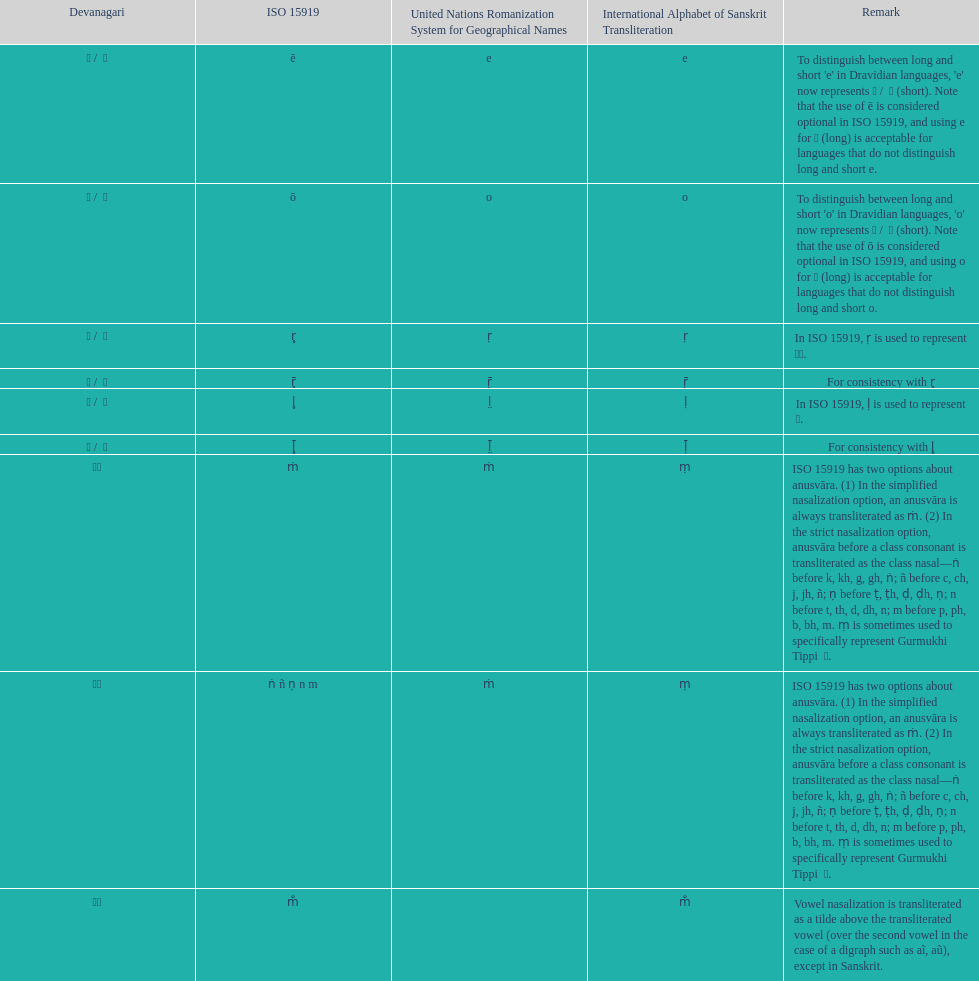Parse the full table. {'header': ['Devanagari', 'ISO 15919', 'United Nations Romanization System for Geographical Names', 'International Alphabet of Sanskrit Transliteration', 'Remark'], 'rows': [['ए / \xa0े', 'ē', 'e', 'e', "To distinguish between long and short 'e' in Dravidian languages, 'e' now represents ऎ / \xa0ॆ (short). Note that the use of ē is considered optional in ISO 15919, and using e for ए (long) is acceptable for languages that do not distinguish long and short e."], ['ओ / \xa0ो', 'ō', 'o', 'o', "To distinguish between long and short 'o' in Dravidian languages, 'o' now represents ऒ / \xa0ॊ (short). Note that the use of ō is considered optional in ISO 15919, and using o for ओ (long) is acceptable for languages that do not distinguish long and short o."], ['ऋ / \xa0ृ', 'r̥', 'ṛ', 'ṛ', 'In ISO 15919, ṛ is used to represent ड़.'], ['ॠ / \xa0ॄ', 'r̥̄', 'ṝ', 'ṝ', 'For consistency with r̥'], ['ऌ / \xa0ॢ', 'l̥', 'l̤', 'ḷ', 'In ISO 15919, ḷ is used to represent ळ.'], ['ॡ / \xa0ॣ', 'l̥̄', 'l̤̄', 'ḹ', 'For consistency with l̥'], ['◌ं', 'ṁ', 'ṁ', 'ṃ', 'ISO 15919 has two options about anusvāra. (1) In the simplified nasalization option, an anusvāra is always transliterated as ṁ. (2) In the strict nasalization option, anusvāra before a class consonant is transliterated as the class nasal—ṅ before k, kh, g, gh, ṅ; ñ before c, ch, j, jh, ñ; ṇ before ṭ, ṭh, ḍ, ḍh, ṇ; n before t, th, d, dh, n; m before p, ph, b, bh, m. ṃ is sometimes used to specifically represent Gurmukhi Tippi \xa0ੰ.'], ['◌ं', 'ṅ ñ ṇ n m', 'ṁ', 'ṃ', 'ISO 15919 has two options about anusvāra. (1) In the simplified nasalization option, an anusvāra is always transliterated as ṁ. (2) In the strict nasalization option, anusvāra before a class consonant is transliterated as the class nasal—ṅ before k, kh, g, gh, ṅ; ñ before c, ch, j, jh, ñ; ṇ before ṭ, ṭh, ḍ, ḍh, ṇ; n before t, th, d, dh, n; m before p, ph, b, bh, m. ṃ is sometimes used to specifically represent Gurmukhi Tippi \xa0ੰ.'], ['◌ँ', 'm̐', '', 'm̐', 'Vowel nasalization is transliterated as a tilde above the transliterated vowel (over the second vowel in the case of a digraph such as aĩ, aũ), except in Sanskrit.']]} What iast is listed before the o? E. 